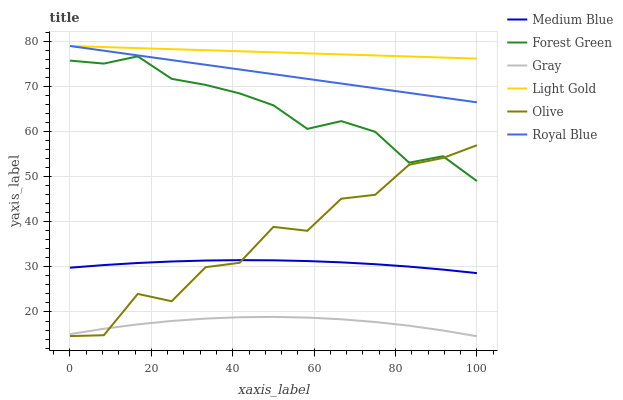Does Gray have the minimum area under the curve?
Answer yes or no. Yes. Does Light Gold have the maximum area under the curve?
Answer yes or no. Yes. Does Medium Blue have the minimum area under the curve?
Answer yes or no. No. Does Medium Blue have the maximum area under the curve?
Answer yes or no. No. Is Light Gold the smoothest?
Answer yes or no. Yes. Is Olive the roughest?
Answer yes or no. Yes. Is Medium Blue the smoothest?
Answer yes or no. No. Is Medium Blue the roughest?
Answer yes or no. No. Does Medium Blue have the lowest value?
Answer yes or no. No. Does Light Gold have the highest value?
Answer yes or no. Yes. Does Medium Blue have the highest value?
Answer yes or no. No. Is Olive less than Light Gold?
Answer yes or no. Yes. Is Forest Green greater than Medium Blue?
Answer yes or no. Yes. Does Royal Blue intersect Light Gold?
Answer yes or no. Yes. Is Royal Blue less than Light Gold?
Answer yes or no. No. Is Royal Blue greater than Light Gold?
Answer yes or no. No. Does Olive intersect Light Gold?
Answer yes or no. No. 